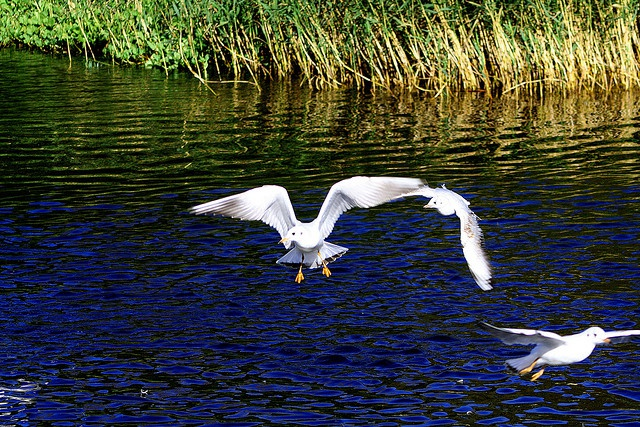Describe the objects in this image and their specific colors. I can see bird in lightgreen, white, darkgray, and black tones, bird in lightgreen, white, black, gray, and darkgray tones, and bird in lightgreen, white, darkgray, black, and gray tones in this image. 